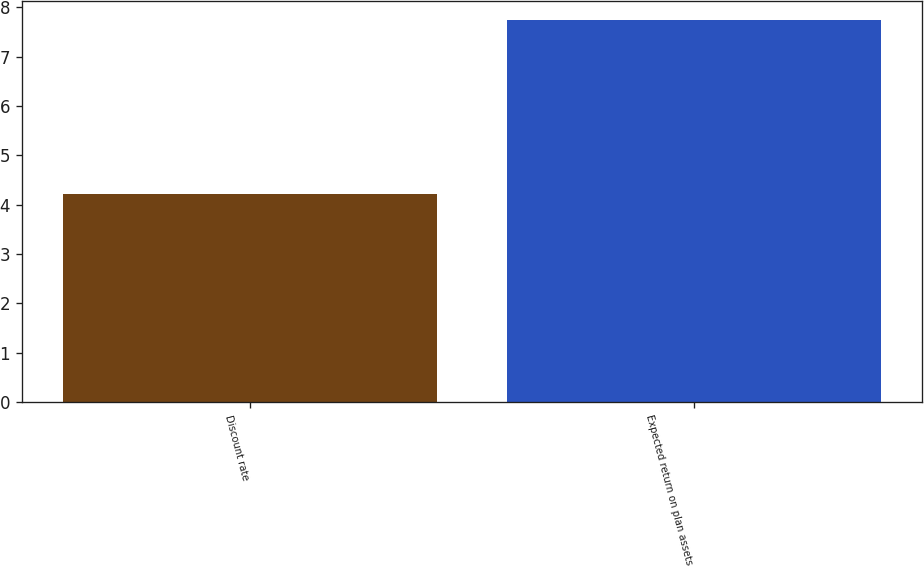Convert chart to OTSL. <chart><loc_0><loc_0><loc_500><loc_500><bar_chart><fcel>Discount rate<fcel>Expected return on plan assets<nl><fcel>4.21<fcel>7.75<nl></chart> 